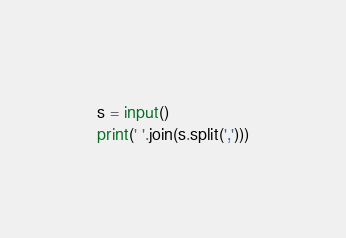<code> <loc_0><loc_0><loc_500><loc_500><_Python_>s = input()
print(' '.join(s.split(',')))</code> 